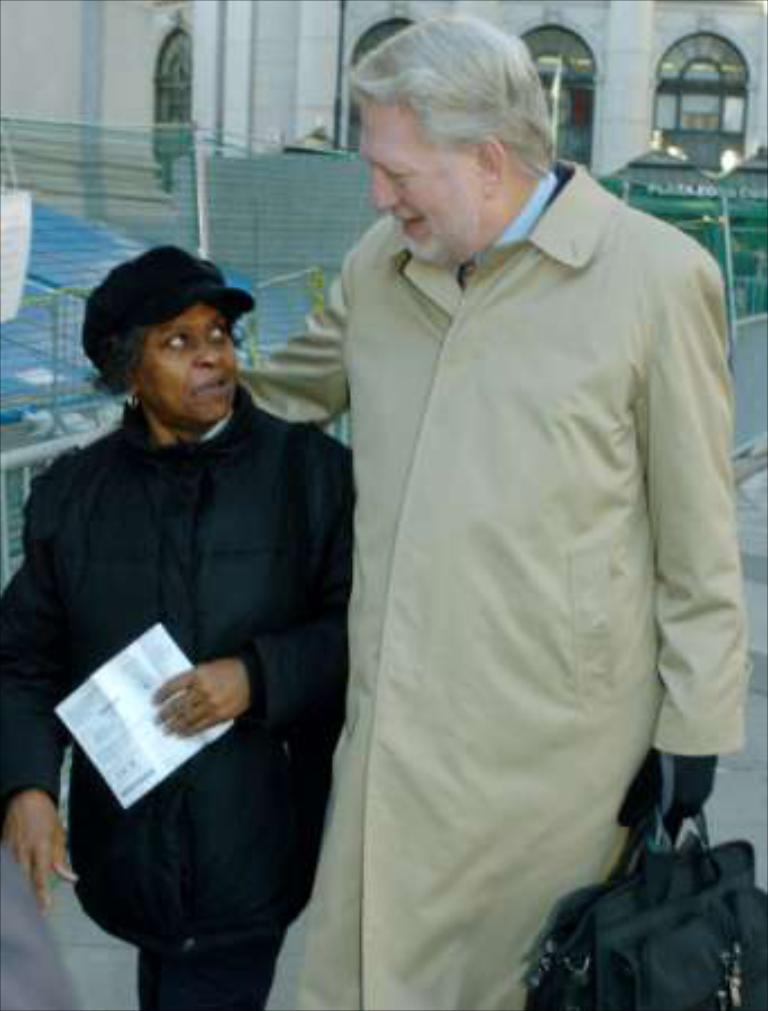How many people are present in the image? There are two people in the image. What are the people holding in the image? The people are holding a paper and a bag. What can be seen in the background of the image? There are fences, objects, and a building with windows in the background of the image. What type of joke can be seen in the image? There is no joke present in the image. Can you see any objects related to space in the image? There are no objects related to space visible in the image. 